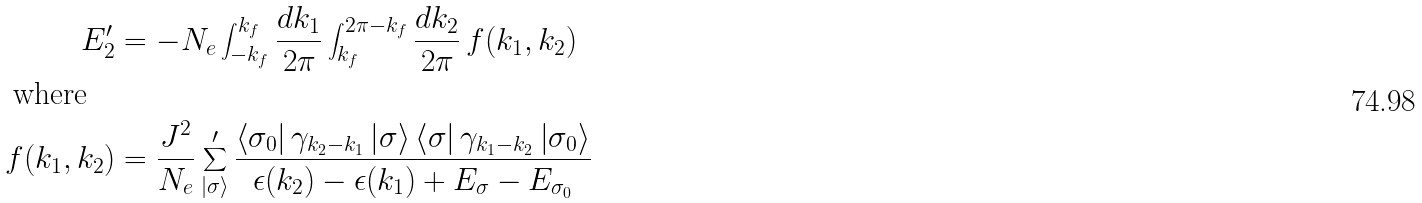<formula> <loc_0><loc_0><loc_500><loc_500>E ^ { \prime } _ { 2 } & = - N _ { e } \int _ { - k _ { f } } ^ { k _ { f } } \frac { d k _ { 1 } } { 2 \pi } \int _ { k _ { f } } ^ { 2 \pi - k _ { f } } \frac { d k _ { 2 } } { 2 \pi } \, f ( k _ { 1 } , k _ { 2 } ) \\ \text {where} \quad & \\ f ( k _ { 1 } , k _ { 2 } ) & = \frac { J ^ { 2 } } { N _ { e } } \sum _ { \left | \sigma \right > } ^ { \prime } \frac { \left < \sigma _ { 0 } \right | \gamma _ { k _ { 2 } - k _ { 1 } } \left | \sigma \right > \left < \sigma \right | \gamma _ { k _ { 1 } - k _ { 2 } } \left | \sigma _ { 0 } \right > } { \epsilon ( k _ { 2 } ) - \epsilon ( k _ { 1 } ) + E _ { \sigma } - E _ { \sigma _ { 0 } } }</formula> 